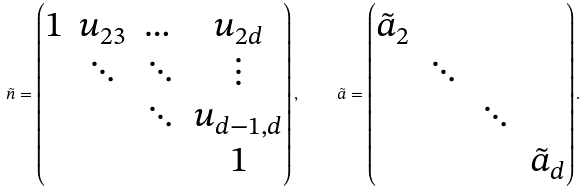Convert formula to latex. <formula><loc_0><loc_0><loc_500><loc_500>\tilde { n } = \begin{pmatrix} 1 & u _ { 2 3 } & \dots & u _ { 2 d } \\ & \ddots & \ddots & \vdots \\ & & \ddots & u _ { d - 1 , d } \\ & & & 1 \end{pmatrix} , \quad \tilde { a } = \begin{pmatrix} \tilde { a } _ { 2 } & & & \\ & \ddots & & \\ & & \ddots & \\ & & & \tilde { a } _ { d } \end{pmatrix} .</formula> 